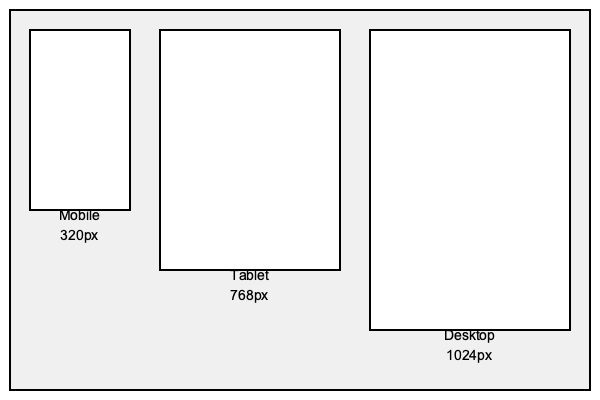Based on the wireframes provided for mobile, tablet, and desktop layouts, what would be the most appropriate responsive design breakpoints to implement? To determine the appropriate responsive design breakpoints, we need to analyze the given wireframes and their respective widths. Let's break it down step-by-step:

1. Identify the device widths:
   - Mobile: 320px
   - Tablet: 768px
   - Desktop: 1024px

2. Consider standard practices:
   - Breakpoints are typically set slightly below the next device size to ensure smooth transitions.
   - It's common to have a small buffer (e.g., 1px) to avoid potential conflicts.

3. Determine the breakpoints:
   a) Mobile to Tablet breakpoint:
      - Set it just below the tablet width: 768px - 1px = 767px
   b) Tablet to Desktop breakpoint:
      - Set it just below the desktop width: 1024px - 1px = 1023px

4. Implement the breakpoints in CSS:
   ```css
   /* Mobile-first approach */
   /* Styles for mobile (default) */

   @media (min-width: 768px) {
     /* Styles for tablet and above */
   }

   @media (min-width: 1024px) {
     /* Styles for desktop */
   }
   ```

By setting these breakpoints, we ensure that the layout transitions smoothly between mobile, tablet, and desktop views, optimizing the user experience across different device sizes.
Answer: 767px and 1023px 